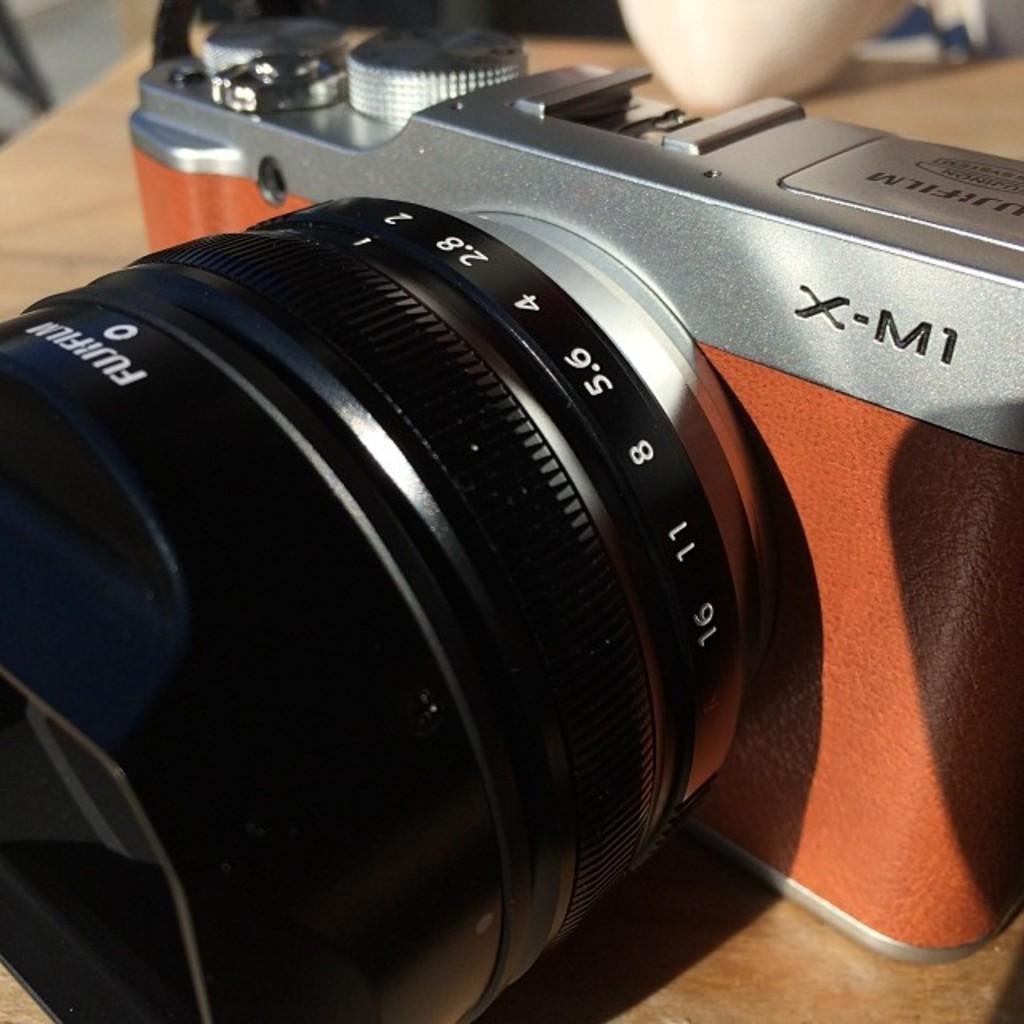Please provide a concise description of this image. In this picture, we can see a camera on a wooden object, and we can see some object in the top right side of the picture. 